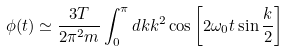<formula> <loc_0><loc_0><loc_500><loc_500>\phi ( t ) \simeq \frac { 3 T } { 2 \pi ^ { 2 } m } \int _ { 0 } ^ { \pi } d k k ^ { 2 } \cos \left [ 2 \omega _ { 0 } t \sin \frac { k } { 2 } \right ]</formula> 